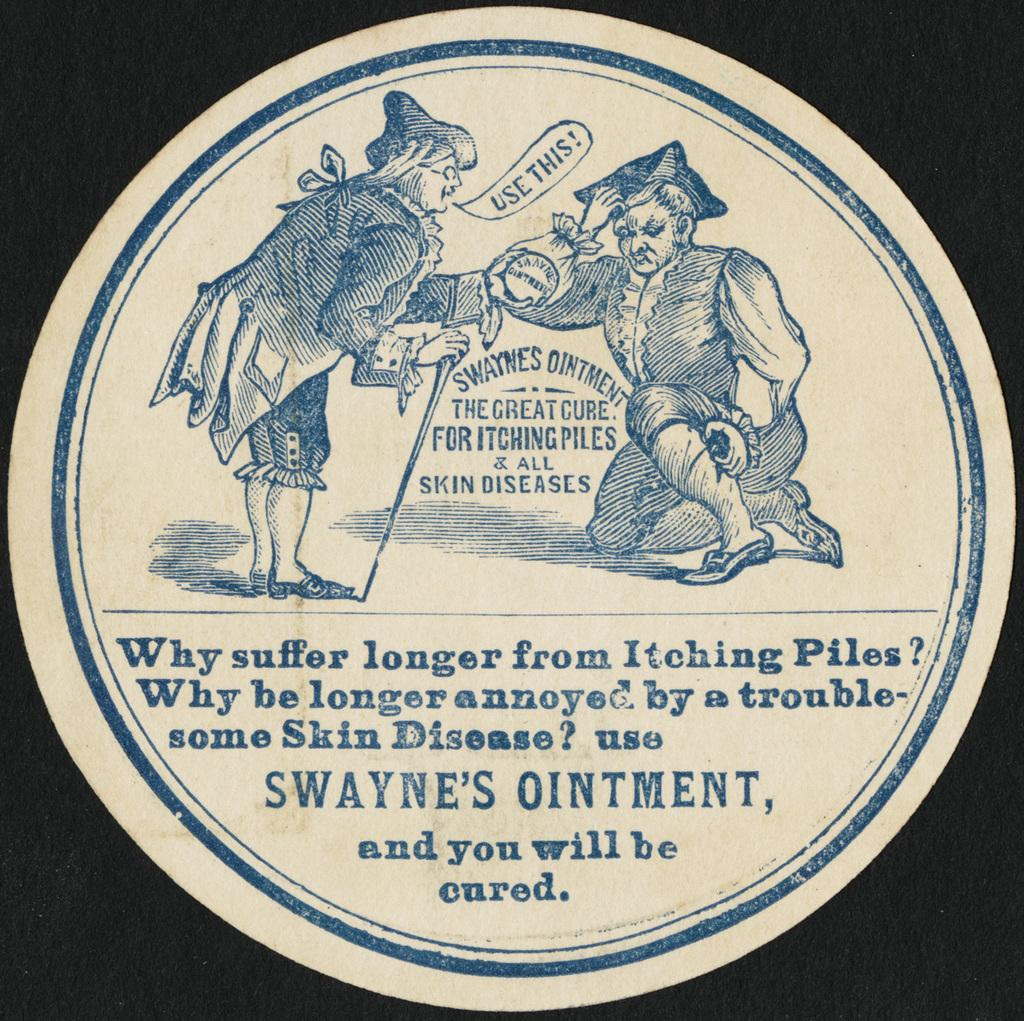What is the main subject in the center of the image? There is an advertisement in the center of the image. How is the advertisement presented? The advertisement is on a round shape paper. Who or what is depicted in the advertisement? There are two persons depicted in the advertisement. Are there any words or phrases in the advertisement? Yes, there is some text in the advertisement. What can be observed about the overall appearance of the image? The background of the image is dark. What type of lead can be seen in the image? There is no lead present in the image. Can you tell me how the two persons in the advertisement are requesting something? The image does not show the two persons making a request; they are depicted in an advertisement. 